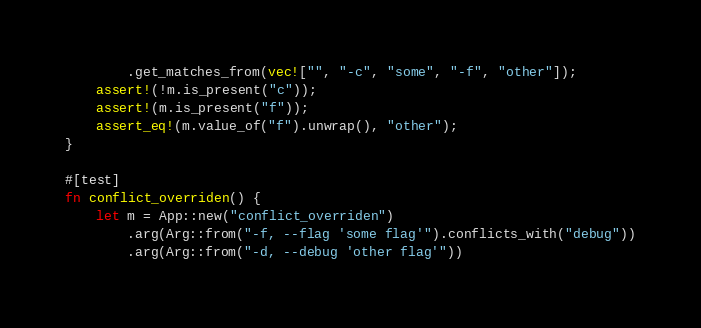Convert code to text. <code><loc_0><loc_0><loc_500><loc_500><_Rust_>        .get_matches_from(vec!["", "-c", "some", "-f", "other"]);
    assert!(!m.is_present("c"));
    assert!(m.is_present("f"));
    assert_eq!(m.value_of("f").unwrap(), "other");
}

#[test]
fn conflict_overriden() {
    let m = App::new("conflict_overriden")
        .arg(Arg::from("-f, --flag 'some flag'").conflicts_with("debug"))
        .arg(Arg::from("-d, --debug 'other flag'"))</code> 